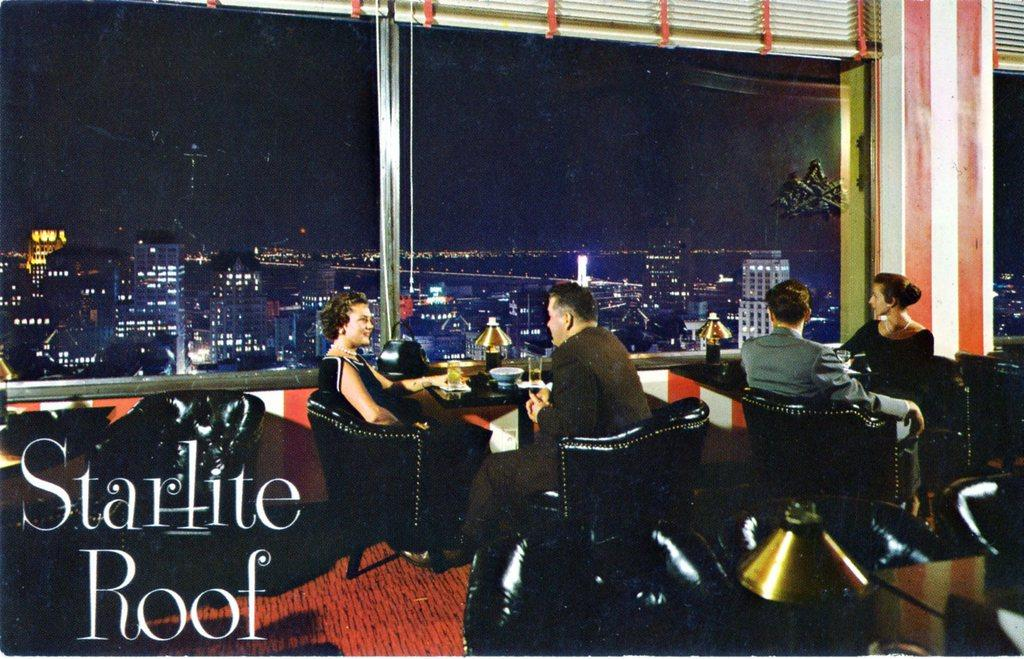What type of establishment is shown in the image? There is a restaurant in the image. How many groups of people are present in the image showing inside the restaurant? There are two couples in the restaurant. What are the couples sitting on? The couples are sitting in chairs. What is placed in front of the couples? There are tables in front of the couples. What can be seen outside the restaurant through a window? There is a night view visible through a window in the restaurant. Are the snails participating in the agreement between the couples in the image? There are no snails present in the image, and therefore they cannot participate in any agreement between the couples. 